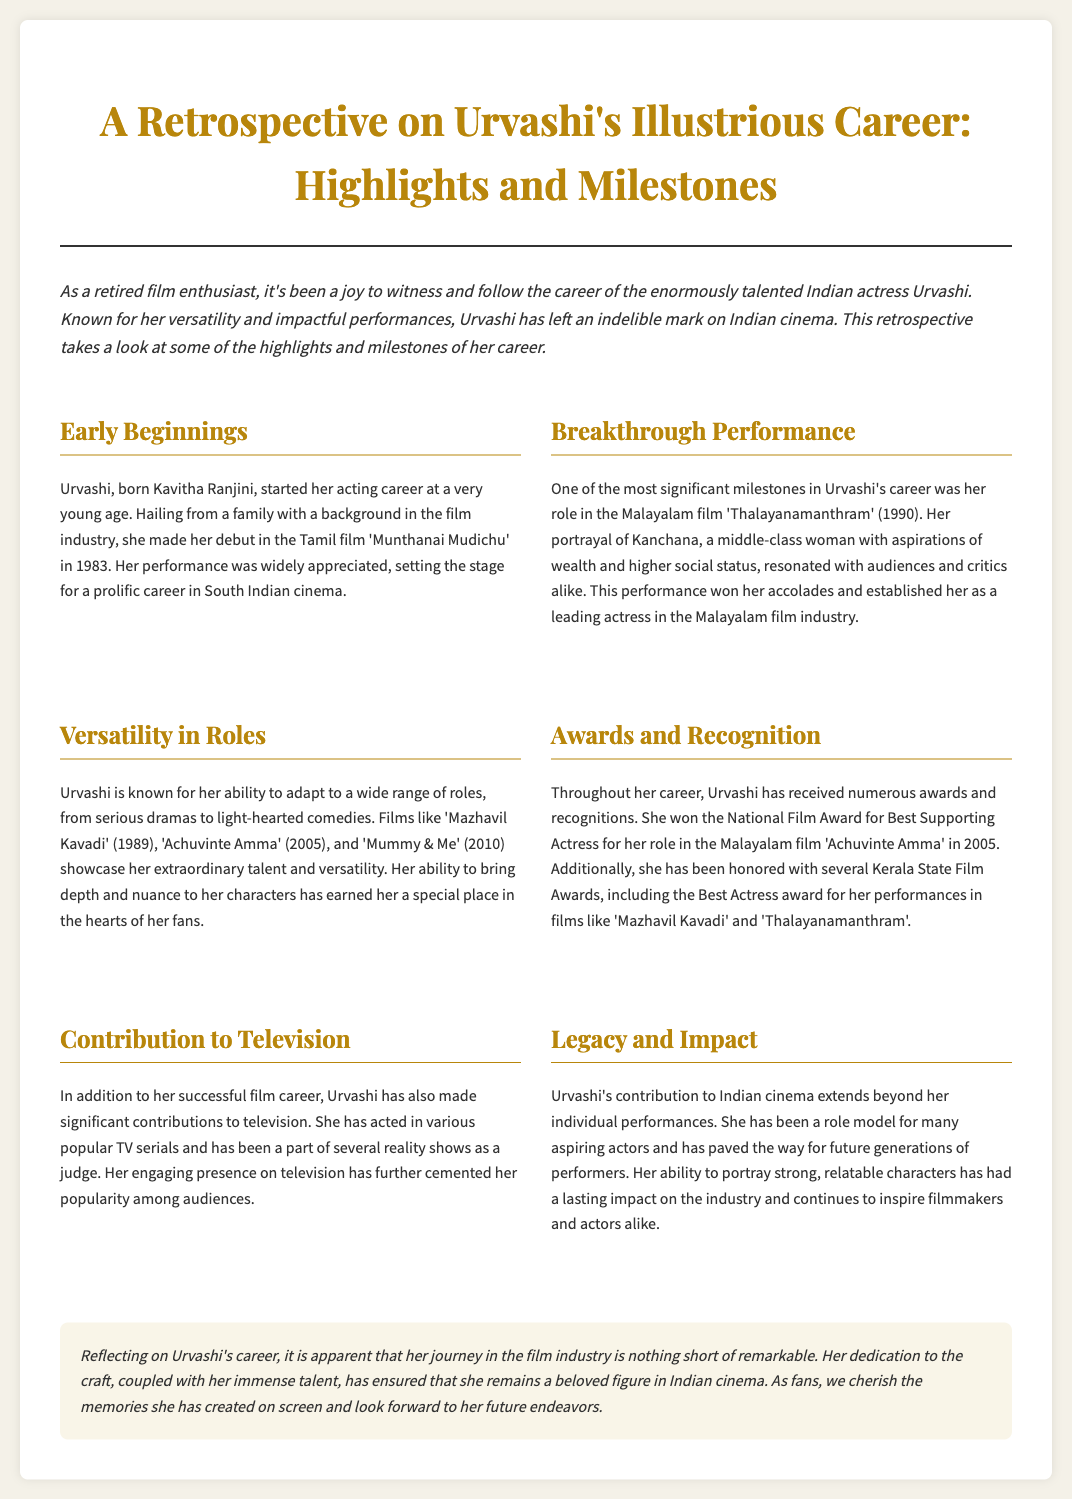What was Urvashi's debut film? Urvashi's debut film is mentioned as 'Munthanai Mudichu,' which she released in 1983.
Answer: Munthanai Mudichu In which film did Urvashi portray Kanchana? The document specifies that Urvashi portrayed Kanchana in the Malayalam film 'Thalayanamanthram' (1990).
Answer: Thalayanamanthram What award did Urvashi win in 2005? The document states that Urvashi won the National Film Award for Best Supporting Actress for her role in 'Achuvinte Amma' in 2005.
Answer: National Film Award for Best Supporting Actress Which film showcases Urvashi's versatility according to the document? The document lists several films, including 'Mazhavil Kavadi,' 'Achuvinte Amma,' and 'Mummy & Me,' showing her versatility.
Answer: Mazhavil Kavadi How has Urvashi contributed to the television industry? The document mentions that Urvashi has acted in popular TV serials and participated in reality shows as a judge, highlighting her television contributions.
Answer: Popular TV serials and reality shows What impact has Urvashi had on future generations of performers? It states that Urvashi has been a role model for many aspiring actors, indicating her positive impact on future generations.
Answer: Role model How many Kerala State Film Awards has Urvashi won? The document does not specify the exact number of Kerala State Film Awards she has won but mentions that she has received several.
Answer: Several What is the main theme of this retrospective article? The retrospective article focuses on highlights and milestones of Urvashi's career in Indian cinema.
Answer: Highlights and milestones of Urvashi's career What is the style of the newspaper heading? The heading is styled to be visually attractive, using a large font and a specific color palette.
Answer: Visually attractive heading 